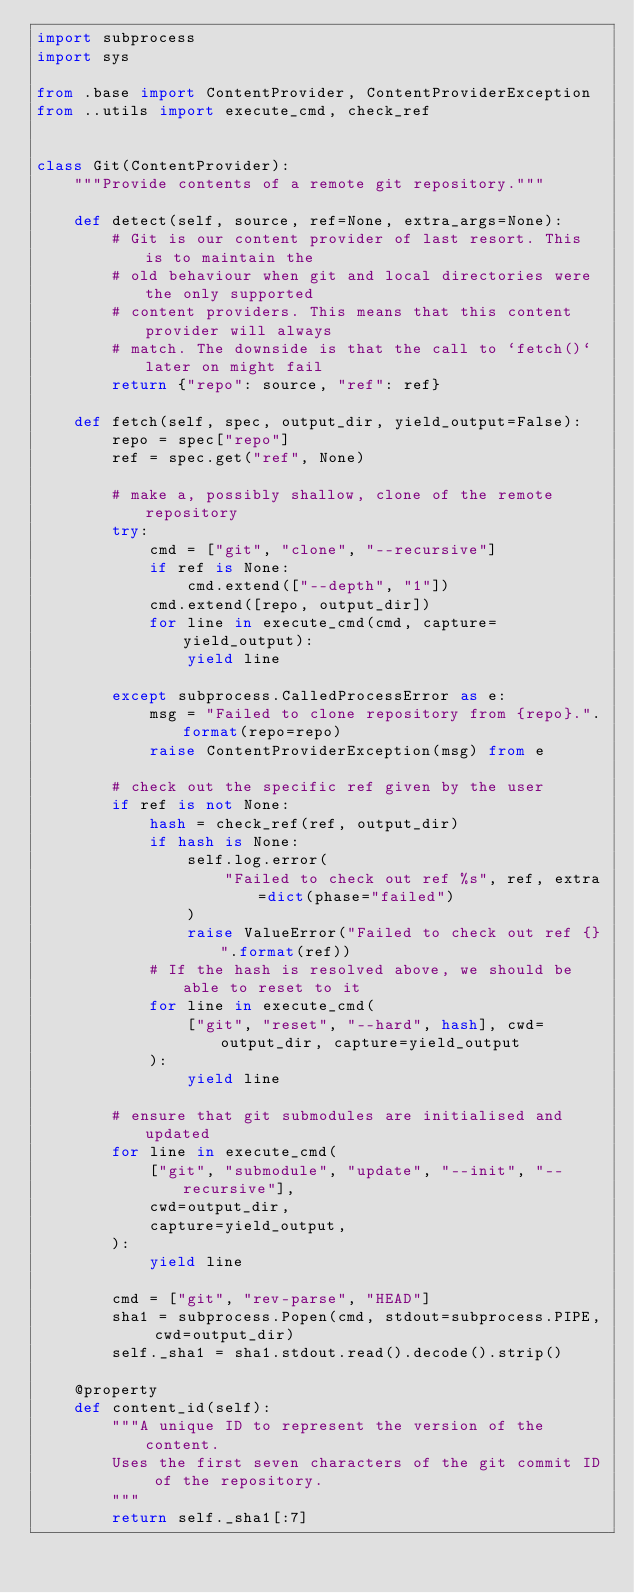Convert code to text. <code><loc_0><loc_0><loc_500><loc_500><_Python_>import subprocess
import sys

from .base import ContentProvider, ContentProviderException
from ..utils import execute_cmd, check_ref


class Git(ContentProvider):
    """Provide contents of a remote git repository."""

    def detect(self, source, ref=None, extra_args=None):
        # Git is our content provider of last resort. This is to maintain the
        # old behaviour when git and local directories were the only supported
        # content providers. This means that this content provider will always
        # match. The downside is that the call to `fetch()` later on might fail
        return {"repo": source, "ref": ref}

    def fetch(self, spec, output_dir, yield_output=False):
        repo = spec["repo"]
        ref = spec.get("ref", None)

        # make a, possibly shallow, clone of the remote repository
        try:
            cmd = ["git", "clone", "--recursive"]
            if ref is None:
                cmd.extend(["--depth", "1"])
            cmd.extend([repo, output_dir])
            for line in execute_cmd(cmd, capture=yield_output):
                yield line

        except subprocess.CalledProcessError as e:
            msg = "Failed to clone repository from {repo}.".format(repo=repo)
            raise ContentProviderException(msg) from e

        # check out the specific ref given by the user
        if ref is not None:
            hash = check_ref(ref, output_dir)
            if hash is None:
                self.log.error(
                    "Failed to check out ref %s", ref, extra=dict(phase="failed")
                )
                raise ValueError("Failed to check out ref {}".format(ref))
            # If the hash is resolved above, we should be able to reset to it
            for line in execute_cmd(
                ["git", "reset", "--hard", hash], cwd=output_dir, capture=yield_output
            ):
                yield line

        # ensure that git submodules are initialised and updated
        for line in execute_cmd(
            ["git", "submodule", "update", "--init", "--recursive"],
            cwd=output_dir,
            capture=yield_output,
        ):
            yield line

        cmd = ["git", "rev-parse", "HEAD"]
        sha1 = subprocess.Popen(cmd, stdout=subprocess.PIPE, cwd=output_dir)
        self._sha1 = sha1.stdout.read().decode().strip()

    @property
    def content_id(self):
        """A unique ID to represent the version of the content.
        Uses the first seven characters of the git commit ID of the repository.
        """
        return self._sha1[:7]
</code> 